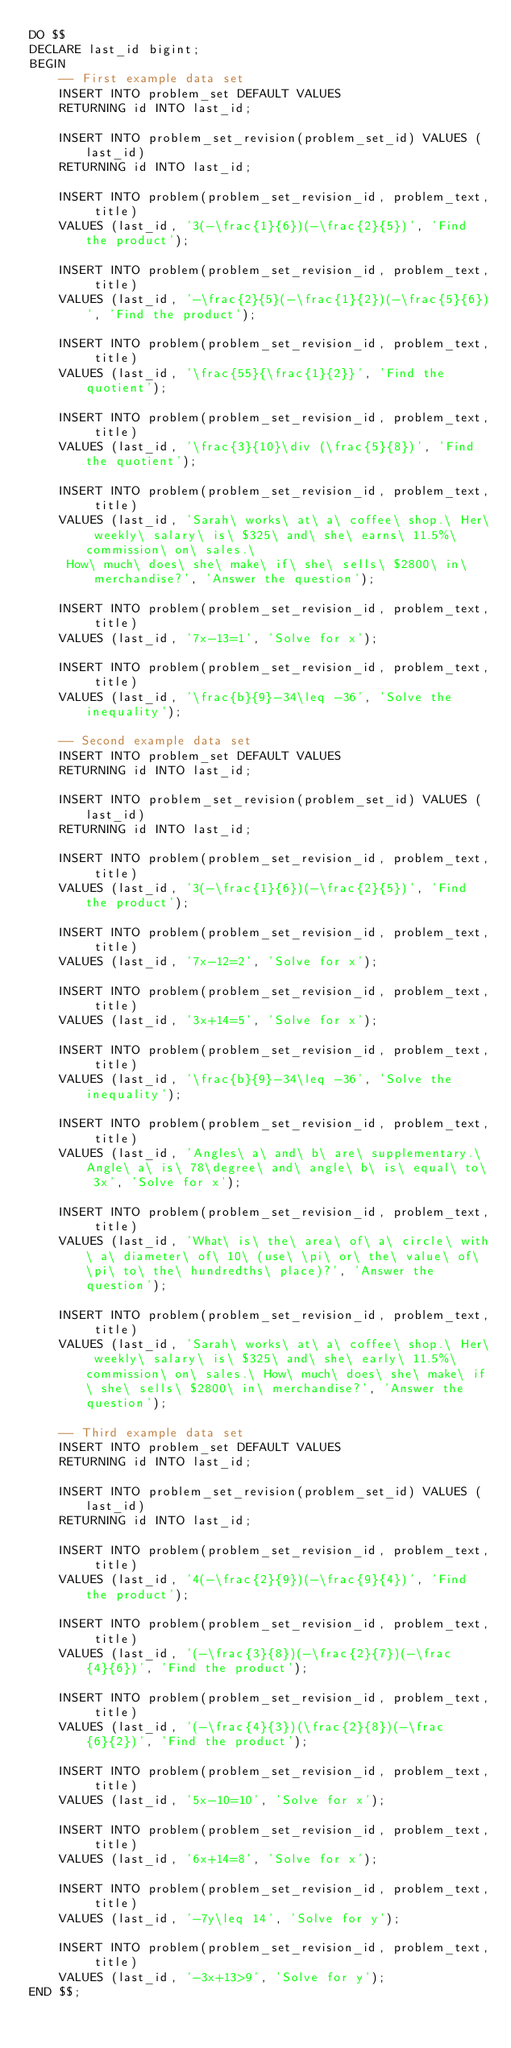Convert code to text. <code><loc_0><loc_0><loc_500><loc_500><_SQL_>DO $$
DECLARE last_id bigint;
BEGIN
    -- First example data set
    INSERT INTO problem_set DEFAULT VALUES
    RETURNING id INTO last_id;

    INSERT INTO problem_set_revision(problem_set_id) VALUES (last_id)
    RETURNING id INTO last_id;

    INSERT INTO problem(problem_set_revision_id, problem_text, title)
    VALUES (last_id, '3(-\frac{1}{6})(-\frac{2}{5})', 'Find the product');

    INSERT INTO problem(problem_set_revision_id, problem_text, title)
    VALUES (last_id, '-\frac{2}{5}(-\frac{1}{2})(-\frac{5}{6})', 'Find the product');

    INSERT INTO problem(problem_set_revision_id, problem_text, title)
    VALUES (last_id, '\frac{55}{\frac{1}{2}}', 'Find the quotient');

    INSERT INTO problem(problem_set_revision_id, problem_text, title)
    VALUES (last_id, '\frac{3}{10}\div (\frac{5}{8})', 'Find the quotient');

    INSERT INTO problem(problem_set_revision_id, problem_text, title)
    VALUES (last_id, 'Sarah\ works\ at\ a\ coffee\ shop.\ Her\ weekly\ salary\ is\ $325\ and\ she\ earns\ 11.5%\ commission\ on\ sales.\
     How\ much\ does\ she\ make\ if\ she\ sells\ $2800\ in\ merchandise?', 'Answer the question');

    INSERT INTO problem(problem_set_revision_id, problem_text, title)
    VALUES (last_id, '7x-13=1', 'Solve for x');

    INSERT INTO problem(problem_set_revision_id, problem_text, title)
    VALUES (last_id, '\frac{b}{9}-34\leq -36', 'Solve the inequality');

    -- Second example data set
    INSERT INTO problem_set DEFAULT VALUES
    RETURNING id INTO last_id;

    INSERT INTO problem_set_revision(problem_set_id) VALUES (last_id)
    RETURNING id INTO last_id;

    INSERT INTO problem(problem_set_revision_id, problem_text, title)
    VALUES (last_id, '3(-\frac{1}{6})(-\frac{2}{5})', 'Find the product');

    INSERT INTO problem(problem_set_revision_id, problem_text, title)
    VALUES (last_id, '7x-12=2', 'Solve for x');

    INSERT INTO problem(problem_set_revision_id, problem_text, title)
    VALUES (last_id, '3x+14=5', 'Solve for x');

    INSERT INTO problem(problem_set_revision_id, problem_text, title)
    VALUES (last_id, '\frac{b}{9}-34\leq -36', 'Solve the inequality');

    INSERT INTO problem(problem_set_revision_id, problem_text, title)
    VALUES (last_id, 'Angles\ a\ and\ b\ are\ supplementary.\ Angle\ a\ is\ 78\degree\ and\ angle\ b\ is\ equal\ to\ 3x', 'Solve for x');

    INSERT INTO problem(problem_set_revision_id, problem_text, title)
    VALUES (last_id, 'What\ is\ the\ area\ of\ a\ circle\ with\ a\ diameter\ of\ 10\ (use\ \pi\ or\ the\ value\ of\ \pi\ to\ the\ hundredths\ place)?', 'Answer the question');

    INSERT INTO problem(problem_set_revision_id, problem_text, title)
    VALUES (last_id, 'Sarah\ works\ at\ a\ coffee\ shop.\ Her\ weekly\ salary\ is\ $325\ and\ she\ early\ 11.5%\ commission\ on\ sales.\ How\ much\ does\ she\ make\ if\ she\ sells\ $2800\ in\ merchandise?', 'Answer the question');

    -- Third example data set
    INSERT INTO problem_set DEFAULT VALUES
    RETURNING id INTO last_id;

    INSERT INTO problem_set_revision(problem_set_id) VALUES (last_id)
    RETURNING id INTO last_id;

    INSERT INTO problem(problem_set_revision_id, problem_text, title)
    VALUES (last_id, '4(-\frac{2}{9})(-\frac{9}{4})', 'Find the product');

    INSERT INTO problem(problem_set_revision_id, problem_text, title)
    VALUES (last_id, '(-\frac{3}{8})(-\frac{2}{7})(-\frac{4}{6})', 'Find the product');

    INSERT INTO problem(problem_set_revision_id, problem_text, title)
    VALUES (last_id, '(-\frac{4}{3})(\frac{2}{8})(-\frac{6}{2})', 'Find the product');

    INSERT INTO problem(problem_set_revision_id, problem_text, title)
    VALUES (last_id, '5x-10=10', 'Solve for x');

    INSERT INTO problem(problem_set_revision_id, problem_text, title)
    VALUES (last_id, '6x+14=8', 'Solve for x');

    INSERT INTO problem(problem_set_revision_id, problem_text, title)
    VALUES (last_id, '-7y\leq 14', 'Solve for y');

    INSERT INTO problem(problem_set_revision_id, problem_text, title)
    VALUES (last_id, '-3x+13>9', 'Solve for y');
END $$;
</code> 